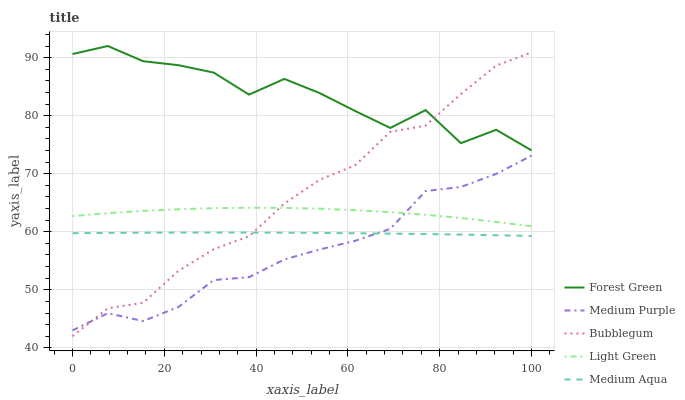Does Medium Purple have the minimum area under the curve?
Answer yes or no. Yes. Does Forest Green have the maximum area under the curve?
Answer yes or no. Yes. Does Medium Aqua have the minimum area under the curve?
Answer yes or no. No. Does Medium Aqua have the maximum area under the curve?
Answer yes or no. No. Is Medium Aqua the smoothest?
Answer yes or no. Yes. Is Forest Green the roughest?
Answer yes or no. Yes. Is Forest Green the smoothest?
Answer yes or no. No. Is Medium Aqua the roughest?
Answer yes or no. No. Does Bubblegum have the lowest value?
Answer yes or no. Yes. Does Medium Aqua have the lowest value?
Answer yes or no. No. Does Forest Green have the highest value?
Answer yes or no. Yes. Does Medium Aqua have the highest value?
Answer yes or no. No. Is Medium Aqua less than Forest Green?
Answer yes or no. Yes. Is Forest Green greater than Medium Aqua?
Answer yes or no. Yes. Does Light Green intersect Medium Purple?
Answer yes or no. Yes. Is Light Green less than Medium Purple?
Answer yes or no. No. Is Light Green greater than Medium Purple?
Answer yes or no. No. Does Medium Aqua intersect Forest Green?
Answer yes or no. No. 